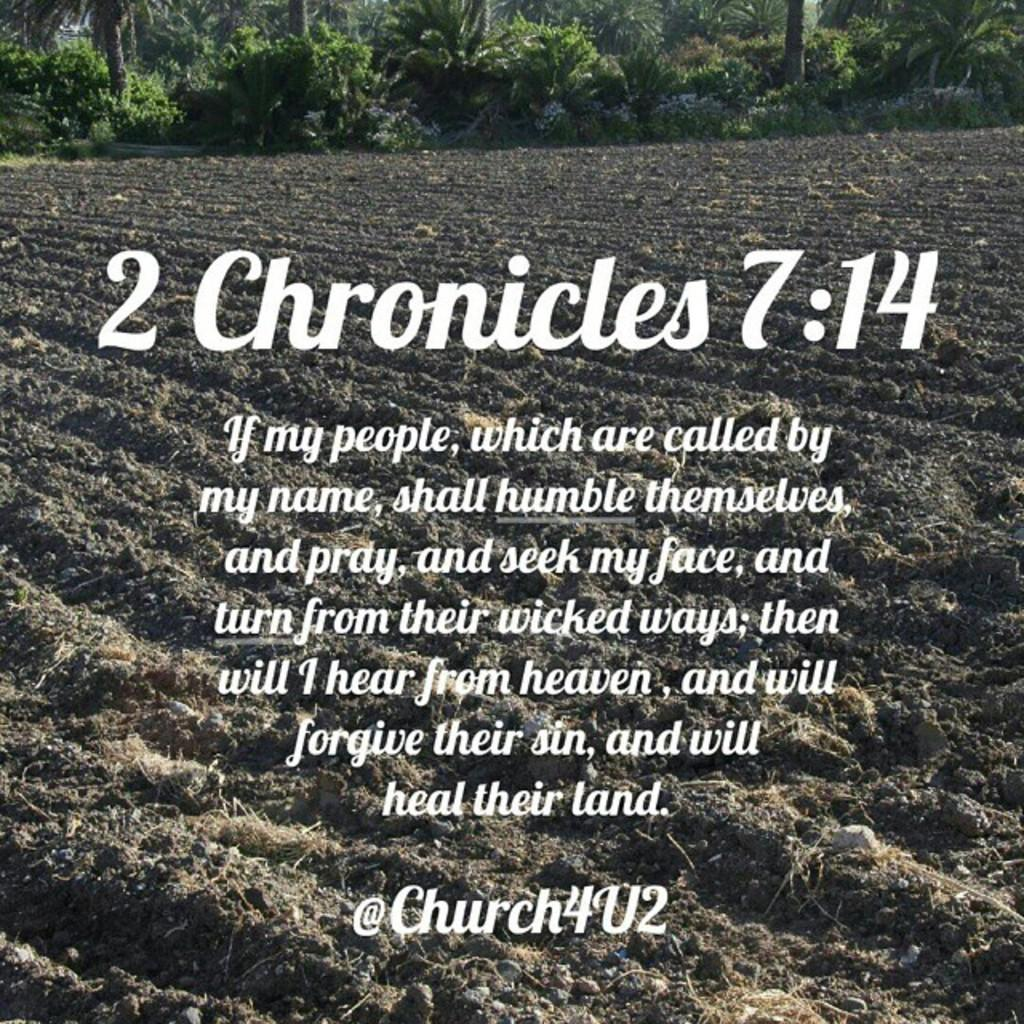What type of vegetation is visible at the top of the image? There are trees at the top of the image. What can be seen in the middle of the image besides the trees? There is some text in the middle of the image. How many spiders are crawling on the text in the image? There are no spiders present in the image. What type of shop or exchange is depicted in the image? There is no shop or exchange depicted in the image; it only features trees and text. 